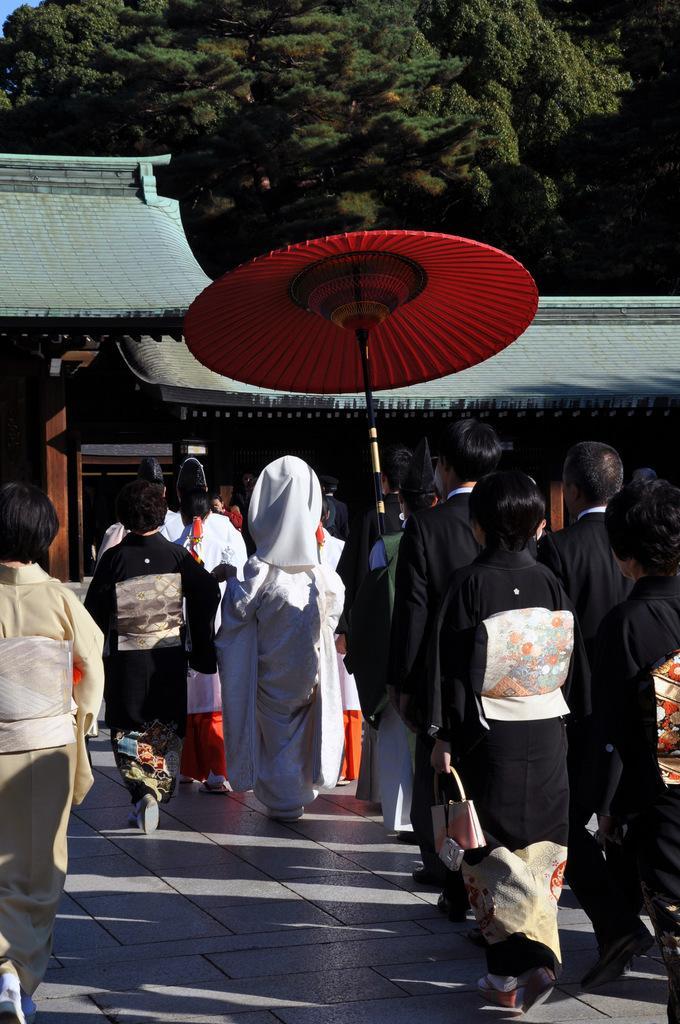Could you give a brief overview of what you see in this image? In this picture there are people on the right and left side of the image and there are roofs and trees in the background area of the image, there is a red color umbrella in the center of the image. 